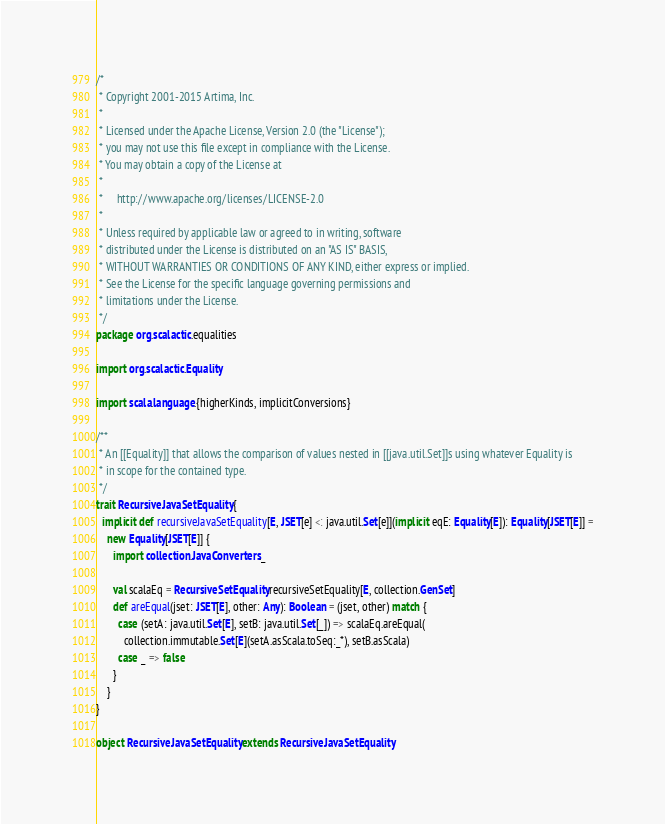<code> <loc_0><loc_0><loc_500><loc_500><_Scala_>/*
 * Copyright 2001-2015 Artima, Inc.
 *
 * Licensed under the Apache License, Version 2.0 (the "License");
 * you may not use this file except in compliance with the License.
 * You may obtain a copy of the License at
 *
 *     http://www.apache.org/licenses/LICENSE-2.0
 *
 * Unless required by applicable law or agreed to in writing, software
 * distributed under the License is distributed on an "AS IS" BASIS,
 * WITHOUT WARRANTIES OR CONDITIONS OF ANY KIND, either express or implied.
 * See the License for the specific language governing permissions and
 * limitations under the License.
 */
package org.scalactic.equalities

import org.scalactic.Equality

import scala.language.{higherKinds, implicitConversions}

/**
 * An [[Equality]] that allows the comparison of values nested in [[java.util.Set]]s using whatever Equality is
 * in scope for the contained type.
 */
trait RecursiveJavaSetEquality {
  implicit def recursiveJavaSetEquality[E, JSET[e] <: java.util.Set[e]](implicit eqE: Equality[E]): Equality[JSET[E]] =
    new Equality[JSET[E]] {
      import collection.JavaConverters._

      val scalaEq = RecursiveSetEquality.recursiveSetEquality[E, collection.GenSet]
      def areEqual(jset: JSET[E], other: Any): Boolean = (jset, other) match {
        case (setA: java.util.Set[E], setB: java.util.Set[_]) => scalaEq.areEqual(
          collection.immutable.Set[E](setA.asScala.toSeq:_*), setB.asScala)
        case _ => false
      }
    }
}

object RecursiveJavaSetEquality extends RecursiveJavaSetEquality
</code> 